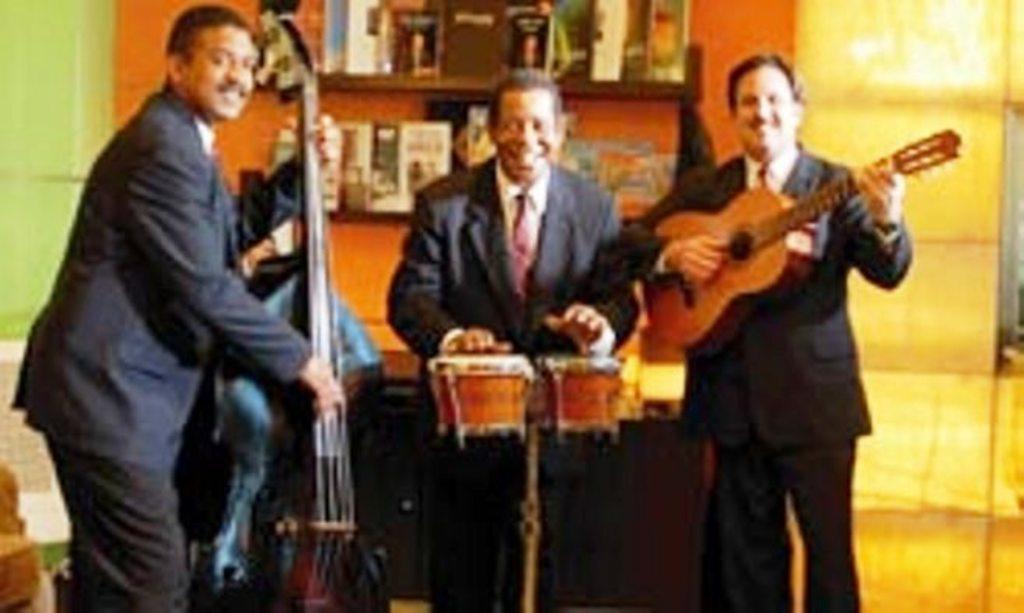Could you give a brief overview of what you see in this image? In the image we can see there are three men and who is holding musical instrument in their hand. three of them are wearing blazers and a tie. 